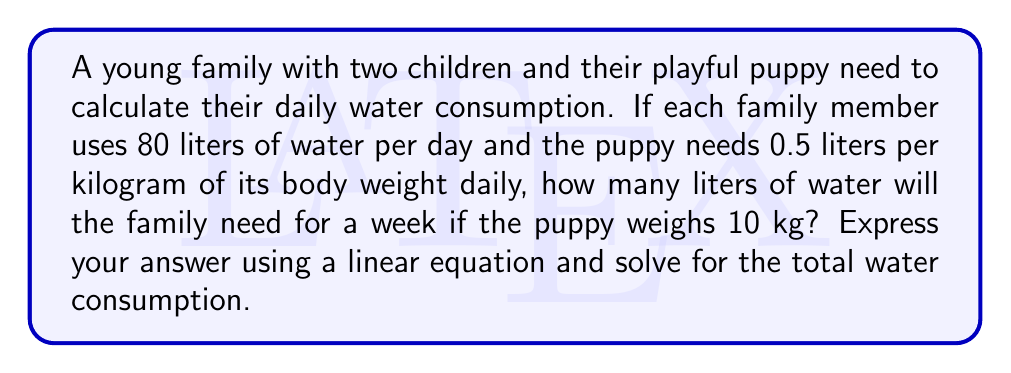Give your solution to this math problem. Let's approach this step-by-step:

1) First, let's define our variables:
   $x$ = total water consumption for the family and puppy for one week

2) Calculate the family's water consumption:
   - Number of family members = 4 (2 adults + 2 children)
   - Daily water consumption per person = 80 liters
   - Daily family consumption = $4 \times 80 = 320$ liters
   - Weekly family consumption = $320 \times 7 = 2240$ liters

3) Calculate the puppy's water consumption:
   - Puppy's weight = 10 kg
   - Daily water need = $0.5$ liters per kg
   - Daily puppy consumption = $10 \times 0.5 = 5$ liters
   - Weekly puppy consumption = $5 \times 7 = 35$ liters

4) Set up the linear equation:
   $$x = 2240 + 35$$

5) Solve the equation:
   $$x = 2275$$

Therefore, the family will need 2275 liters of water for one week.
Answer: $x = 2275$ liters 